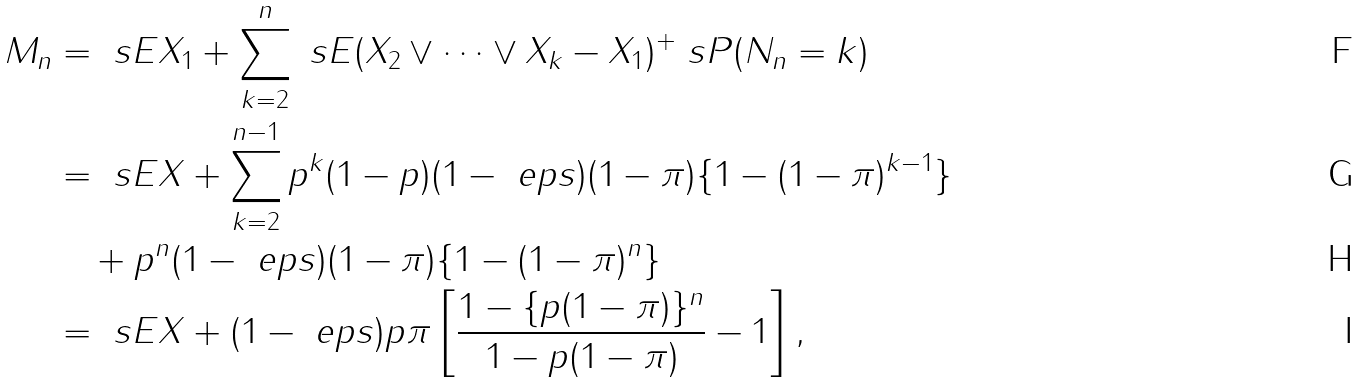<formula> <loc_0><loc_0><loc_500><loc_500>M _ { n } & = \ s E X _ { 1 } + \sum _ { k = 2 } ^ { n } \ s E ( X _ { 2 } \vee \dots \vee X _ { k } - X _ { 1 } ) ^ { + } \ s P ( N _ { n } = k ) \\ & = \ s E X + \sum _ { k = 2 } ^ { n - 1 } p ^ { k } ( 1 - p ) ( 1 - \ e p s ) ( 1 - \pi ) \{ 1 - ( 1 - \pi ) ^ { k - 1 } \} \\ & \quad + p ^ { n } ( 1 - \ e p s ) ( 1 - \pi ) \{ 1 - ( 1 - \pi ) ^ { n } \} \\ & = \ s E X + ( 1 - \ e p s ) p \pi \left [ \frac { 1 - \{ p ( 1 - \pi ) \} ^ { n } } { 1 - p ( 1 - \pi ) } - 1 \right ] ,</formula> 